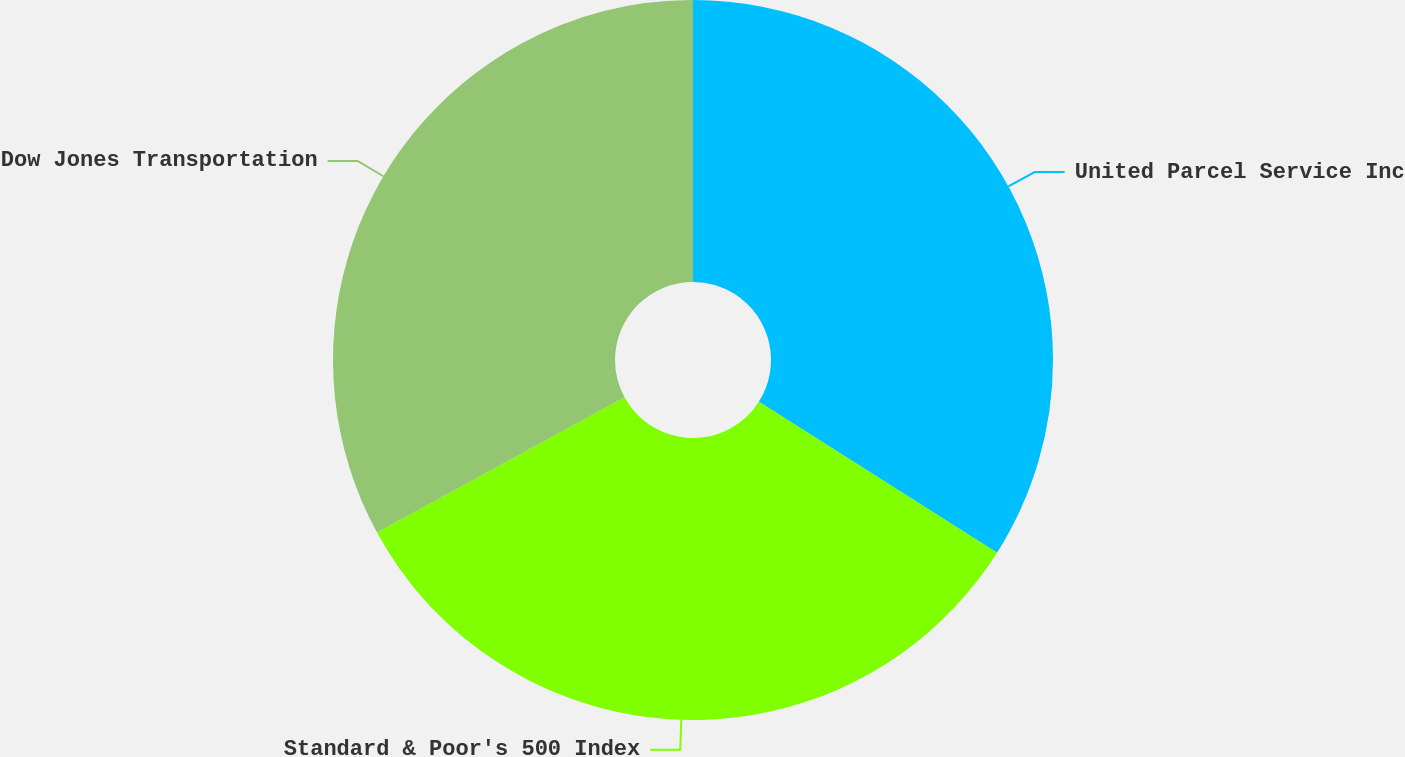Convert chart to OTSL. <chart><loc_0><loc_0><loc_500><loc_500><pie_chart><fcel>United Parcel Service Inc<fcel>Standard & Poor's 500 Index<fcel>Dow Jones Transportation<nl><fcel>33.99%<fcel>33.06%<fcel>32.95%<nl></chart> 